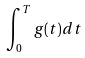<formula> <loc_0><loc_0><loc_500><loc_500>\int _ { 0 } ^ { T } g ( t ) d t</formula> 